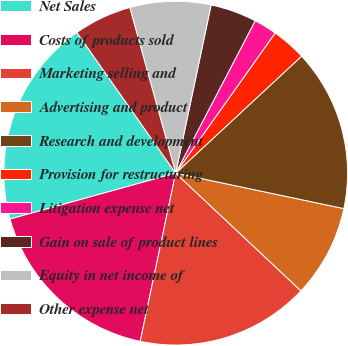<chart> <loc_0><loc_0><loc_500><loc_500><pie_chart><fcel>Net Sales<fcel>Costs of products sold<fcel>Marketing selling and<fcel>Advertising and product<fcel>Research and development<fcel>Provision for restructuring<fcel>Litigation expense net<fcel>Gain on sale of product lines<fcel>Equity in net income of<fcel>Other expense net<nl><fcel>19.56%<fcel>17.39%<fcel>16.3%<fcel>8.7%<fcel>15.22%<fcel>3.26%<fcel>2.17%<fcel>4.35%<fcel>7.61%<fcel>5.44%<nl></chart> 